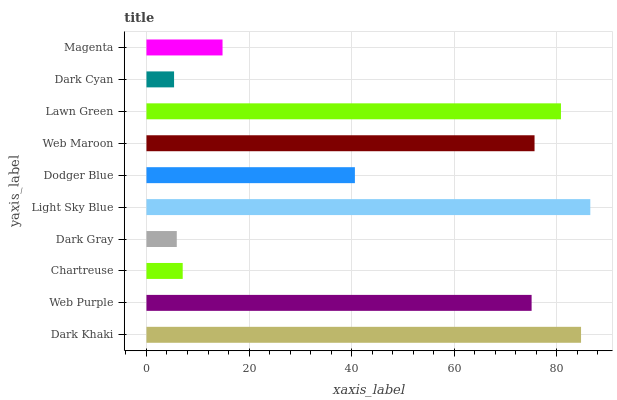Is Dark Cyan the minimum?
Answer yes or no. Yes. Is Light Sky Blue the maximum?
Answer yes or no. Yes. Is Web Purple the minimum?
Answer yes or no. No. Is Web Purple the maximum?
Answer yes or no. No. Is Dark Khaki greater than Web Purple?
Answer yes or no. Yes. Is Web Purple less than Dark Khaki?
Answer yes or no. Yes. Is Web Purple greater than Dark Khaki?
Answer yes or no. No. Is Dark Khaki less than Web Purple?
Answer yes or no. No. Is Web Purple the high median?
Answer yes or no. Yes. Is Dodger Blue the low median?
Answer yes or no. Yes. Is Dark Khaki the high median?
Answer yes or no. No. Is Dark Gray the low median?
Answer yes or no. No. 